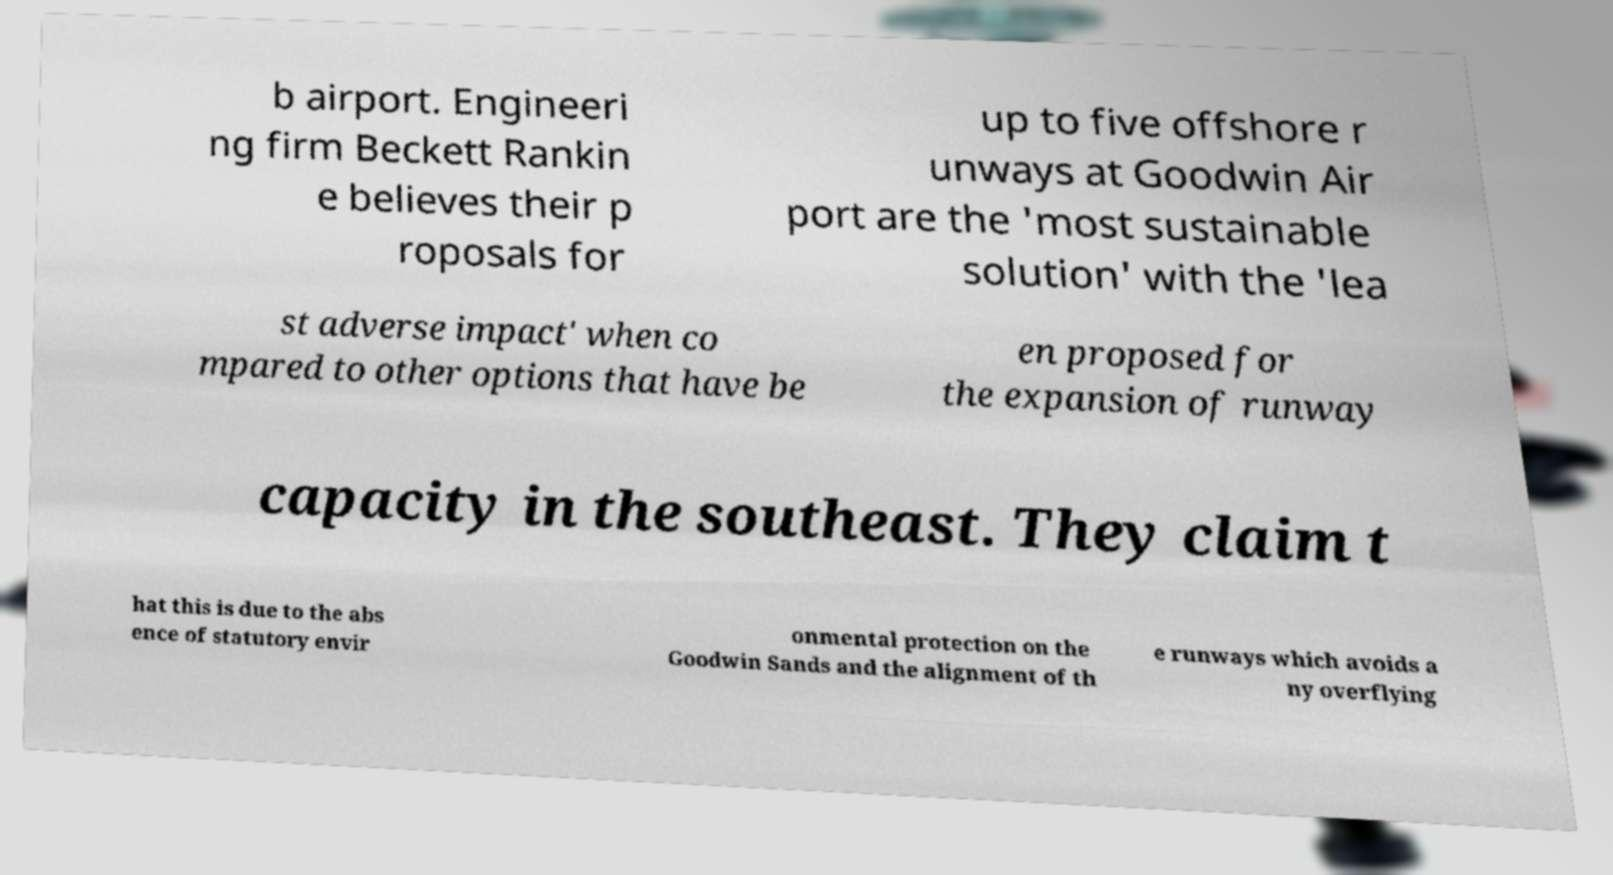Please read and relay the text visible in this image. What does it say? b airport. Engineeri ng firm Beckett Rankin e believes their p roposals for up to five offshore r unways at Goodwin Air port are the 'most sustainable solution' with the 'lea st adverse impact' when co mpared to other options that have be en proposed for the expansion of runway capacity in the southeast. They claim t hat this is due to the abs ence of statutory envir onmental protection on the Goodwin Sands and the alignment of th e runways which avoids a ny overflying 